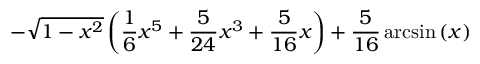<formula> <loc_0><loc_0><loc_500><loc_500>- \sqrt { 1 - x ^ { 2 } } \left ( \frac { 1 } { 6 } x ^ { 5 } + \frac { 5 } { 2 4 } x ^ { 3 } + \frac { 5 } { 1 6 } x \right ) + \frac { 5 } { 1 6 } \arcsin \left ( x \right )</formula> 